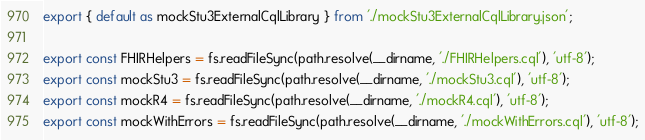Convert code to text. <code><loc_0><loc_0><loc_500><loc_500><_JavaScript_>export { default as mockStu3ExternalCqlLibrary } from './mockStu3ExternalCqlLibrary.json';

export const FHIRHelpers = fs.readFileSync(path.resolve(__dirname, './FHIRHelpers.cql'), 'utf-8');
export const mockStu3 = fs.readFileSync(path.resolve(__dirname, './mockStu3.cql'), 'utf-8');
export const mockR4 = fs.readFileSync(path.resolve(__dirname, './mockR4.cql'), 'utf-8');
export const mockWithErrors = fs.readFileSync(path.resolve(__dirname, './mockWithErrors.cql'), 'utf-8');
</code> 